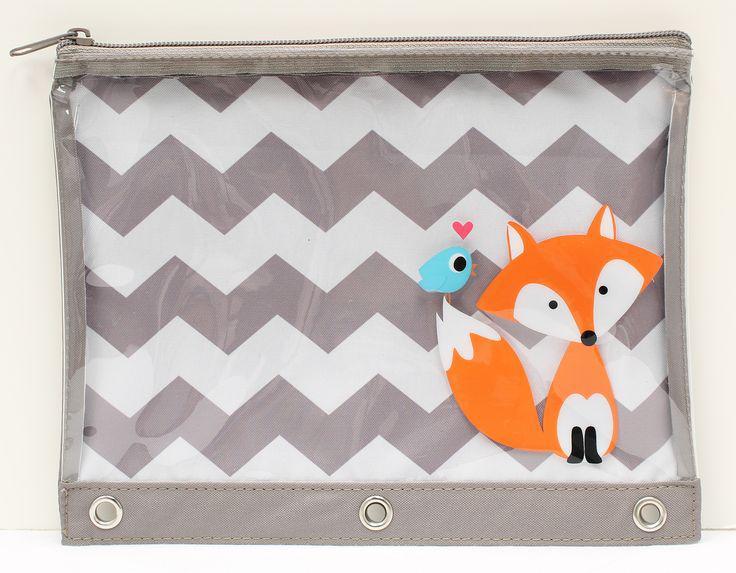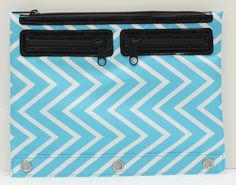The first image is the image on the left, the second image is the image on the right. Assess this claim about the two images: "for the image on the right side, the bag has black and white zigzags.". Correct or not? Answer yes or no. No. 